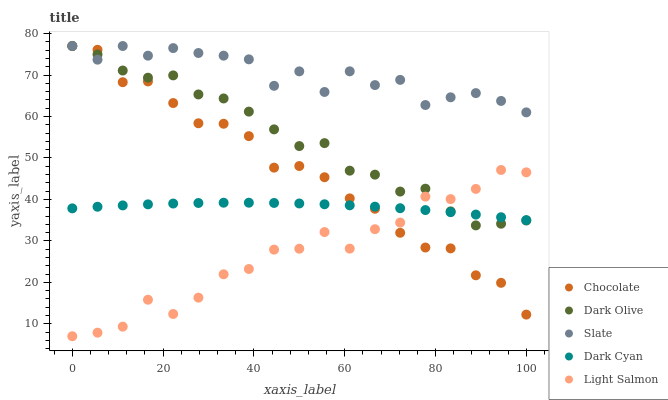Does Light Salmon have the minimum area under the curve?
Answer yes or no. Yes. Does Slate have the maximum area under the curve?
Answer yes or no. Yes. Does Dark Olive have the minimum area under the curve?
Answer yes or no. No. Does Dark Olive have the maximum area under the curve?
Answer yes or no. No. Is Dark Cyan the smoothest?
Answer yes or no. Yes. Is Slate the roughest?
Answer yes or no. Yes. Is Dark Olive the smoothest?
Answer yes or no. No. Is Dark Olive the roughest?
Answer yes or no. No. Does Light Salmon have the lowest value?
Answer yes or no. Yes. Does Dark Olive have the lowest value?
Answer yes or no. No. Does Chocolate have the highest value?
Answer yes or no. Yes. Does Light Salmon have the highest value?
Answer yes or no. No. Is Light Salmon less than Slate?
Answer yes or no. Yes. Is Slate greater than Light Salmon?
Answer yes or no. Yes. Does Dark Olive intersect Slate?
Answer yes or no. Yes. Is Dark Olive less than Slate?
Answer yes or no. No. Is Dark Olive greater than Slate?
Answer yes or no. No. Does Light Salmon intersect Slate?
Answer yes or no. No. 